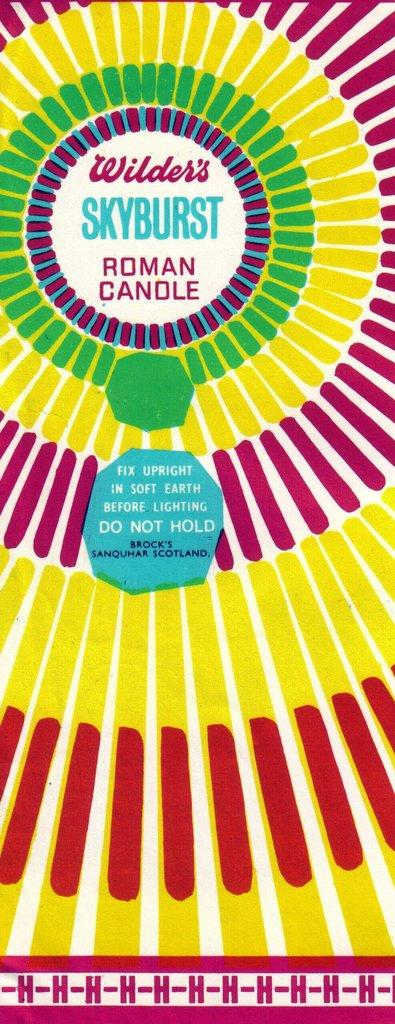<image>
Provide a brief description of the given image. a poster of wilders skyburst roman candle firework 